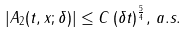Convert formula to latex. <formula><loc_0><loc_0><loc_500><loc_500>| A _ { 2 } ( t , x ; \delta ) | \leq C \, ( \delta t ) ^ { \frac { 5 } { 4 } } , \, a . s .</formula> 